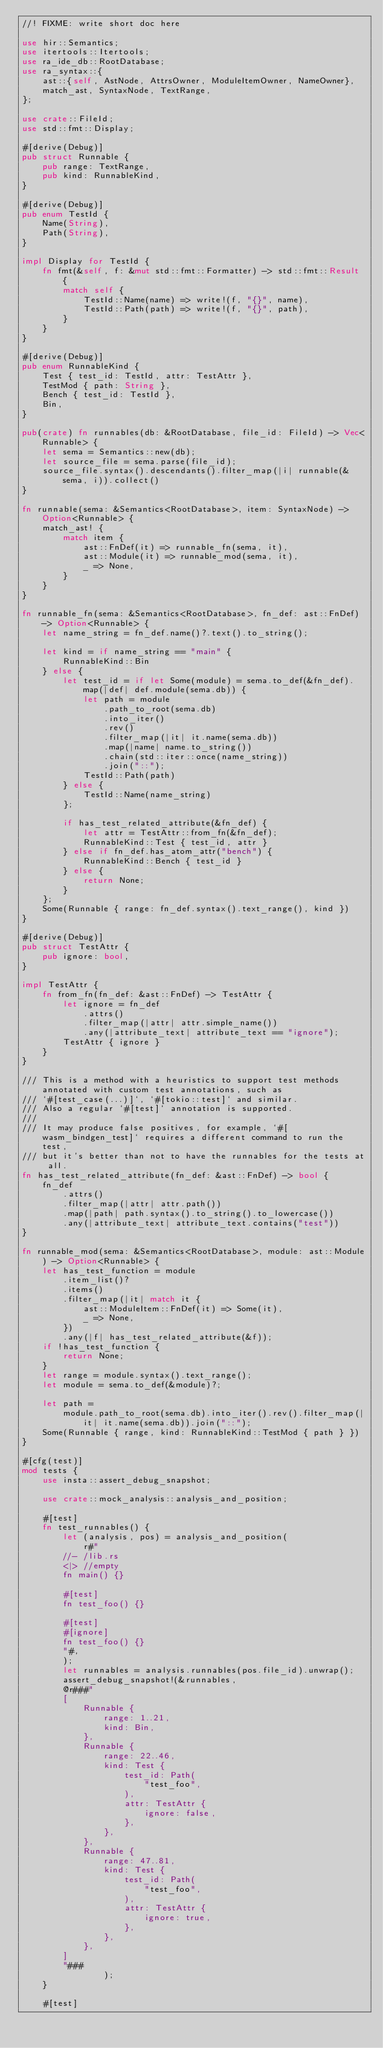Convert code to text. <code><loc_0><loc_0><loc_500><loc_500><_Rust_>//! FIXME: write short doc here

use hir::Semantics;
use itertools::Itertools;
use ra_ide_db::RootDatabase;
use ra_syntax::{
    ast::{self, AstNode, AttrsOwner, ModuleItemOwner, NameOwner},
    match_ast, SyntaxNode, TextRange,
};

use crate::FileId;
use std::fmt::Display;

#[derive(Debug)]
pub struct Runnable {
    pub range: TextRange,
    pub kind: RunnableKind,
}

#[derive(Debug)]
pub enum TestId {
    Name(String),
    Path(String),
}

impl Display for TestId {
    fn fmt(&self, f: &mut std::fmt::Formatter) -> std::fmt::Result {
        match self {
            TestId::Name(name) => write!(f, "{}", name),
            TestId::Path(path) => write!(f, "{}", path),
        }
    }
}

#[derive(Debug)]
pub enum RunnableKind {
    Test { test_id: TestId, attr: TestAttr },
    TestMod { path: String },
    Bench { test_id: TestId },
    Bin,
}

pub(crate) fn runnables(db: &RootDatabase, file_id: FileId) -> Vec<Runnable> {
    let sema = Semantics::new(db);
    let source_file = sema.parse(file_id);
    source_file.syntax().descendants().filter_map(|i| runnable(&sema, i)).collect()
}

fn runnable(sema: &Semantics<RootDatabase>, item: SyntaxNode) -> Option<Runnable> {
    match_ast! {
        match item {
            ast::FnDef(it) => runnable_fn(sema, it),
            ast::Module(it) => runnable_mod(sema, it),
            _ => None,
        }
    }
}

fn runnable_fn(sema: &Semantics<RootDatabase>, fn_def: ast::FnDef) -> Option<Runnable> {
    let name_string = fn_def.name()?.text().to_string();

    let kind = if name_string == "main" {
        RunnableKind::Bin
    } else {
        let test_id = if let Some(module) = sema.to_def(&fn_def).map(|def| def.module(sema.db)) {
            let path = module
                .path_to_root(sema.db)
                .into_iter()
                .rev()
                .filter_map(|it| it.name(sema.db))
                .map(|name| name.to_string())
                .chain(std::iter::once(name_string))
                .join("::");
            TestId::Path(path)
        } else {
            TestId::Name(name_string)
        };

        if has_test_related_attribute(&fn_def) {
            let attr = TestAttr::from_fn(&fn_def);
            RunnableKind::Test { test_id, attr }
        } else if fn_def.has_atom_attr("bench") {
            RunnableKind::Bench { test_id }
        } else {
            return None;
        }
    };
    Some(Runnable { range: fn_def.syntax().text_range(), kind })
}

#[derive(Debug)]
pub struct TestAttr {
    pub ignore: bool,
}

impl TestAttr {
    fn from_fn(fn_def: &ast::FnDef) -> TestAttr {
        let ignore = fn_def
            .attrs()
            .filter_map(|attr| attr.simple_name())
            .any(|attribute_text| attribute_text == "ignore");
        TestAttr { ignore }
    }
}

/// This is a method with a heuristics to support test methods annotated with custom test annotations, such as
/// `#[test_case(...)]`, `#[tokio::test]` and similar.
/// Also a regular `#[test]` annotation is supported.
///
/// It may produce false positives, for example, `#[wasm_bindgen_test]` requires a different command to run the test,
/// but it's better than not to have the runnables for the tests at all.
fn has_test_related_attribute(fn_def: &ast::FnDef) -> bool {
    fn_def
        .attrs()
        .filter_map(|attr| attr.path())
        .map(|path| path.syntax().to_string().to_lowercase())
        .any(|attribute_text| attribute_text.contains("test"))
}

fn runnable_mod(sema: &Semantics<RootDatabase>, module: ast::Module) -> Option<Runnable> {
    let has_test_function = module
        .item_list()?
        .items()
        .filter_map(|it| match it {
            ast::ModuleItem::FnDef(it) => Some(it),
            _ => None,
        })
        .any(|f| has_test_related_attribute(&f));
    if !has_test_function {
        return None;
    }
    let range = module.syntax().text_range();
    let module = sema.to_def(&module)?;

    let path =
        module.path_to_root(sema.db).into_iter().rev().filter_map(|it| it.name(sema.db)).join("::");
    Some(Runnable { range, kind: RunnableKind::TestMod { path } })
}

#[cfg(test)]
mod tests {
    use insta::assert_debug_snapshot;

    use crate::mock_analysis::analysis_and_position;

    #[test]
    fn test_runnables() {
        let (analysis, pos) = analysis_and_position(
            r#"
        //- /lib.rs
        <|> //empty
        fn main() {}

        #[test]
        fn test_foo() {}

        #[test]
        #[ignore]
        fn test_foo() {}
        "#,
        );
        let runnables = analysis.runnables(pos.file_id).unwrap();
        assert_debug_snapshot!(&runnables,
        @r###"
        [
            Runnable {
                range: 1..21,
                kind: Bin,
            },
            Runnable {
                range: 22..46,
                kind: Test {
                    test_id: Path(
                        "test_foo",
                    ),
                    attr: TestAttr {
                        ignore: false,
                    },
                },
            },
            Runnable {
                range: 47..81,
                kind: Test {
                    test_id: Path(
                        "test_foo",
                    ),
                    attr: TestAttr {
                        ignore: true,
                    },
                },
            },
        ]
        "###
                );
    }

    #[test]</code> 